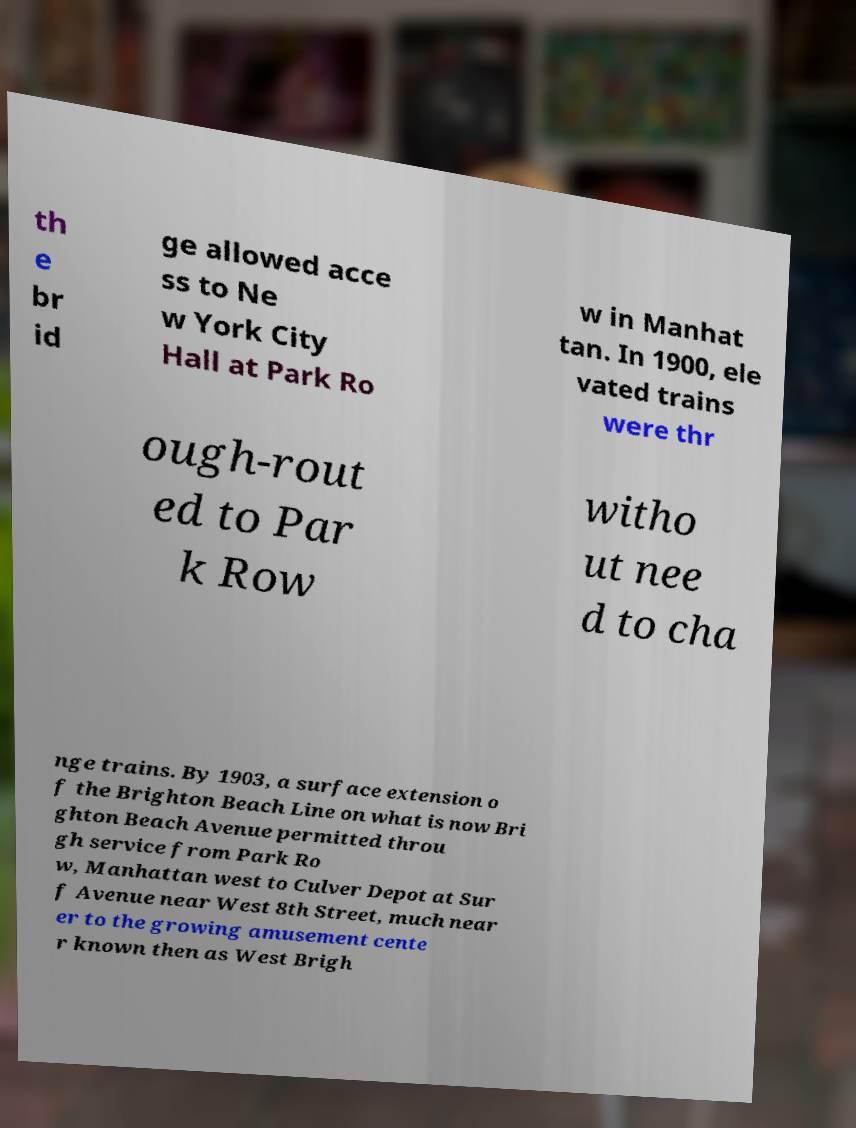I need the written content from this picture converted into text. Can you do that? th e br id ge allowed acce ss to Ne w York City Hall at Park Ro w in Manhat tan. In 1900, ele vated trains were thr ough-rout ed to Par k Row witho ut nee d to cha nge trains. By 1903, a surface extension o f the Brighton Beach Line on what is now Bri ghton Beach Avenue permitted throu gh service from Park Ro w, Manhattan west to Culver Depot at Sur f Avenue near West 8th Street, much near er to the growing amusement cente r known then as West Brigh 